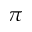Convert formula to latex. <formula><loc_0><loc_0><loc_500><loc_500>\pi</formula> 